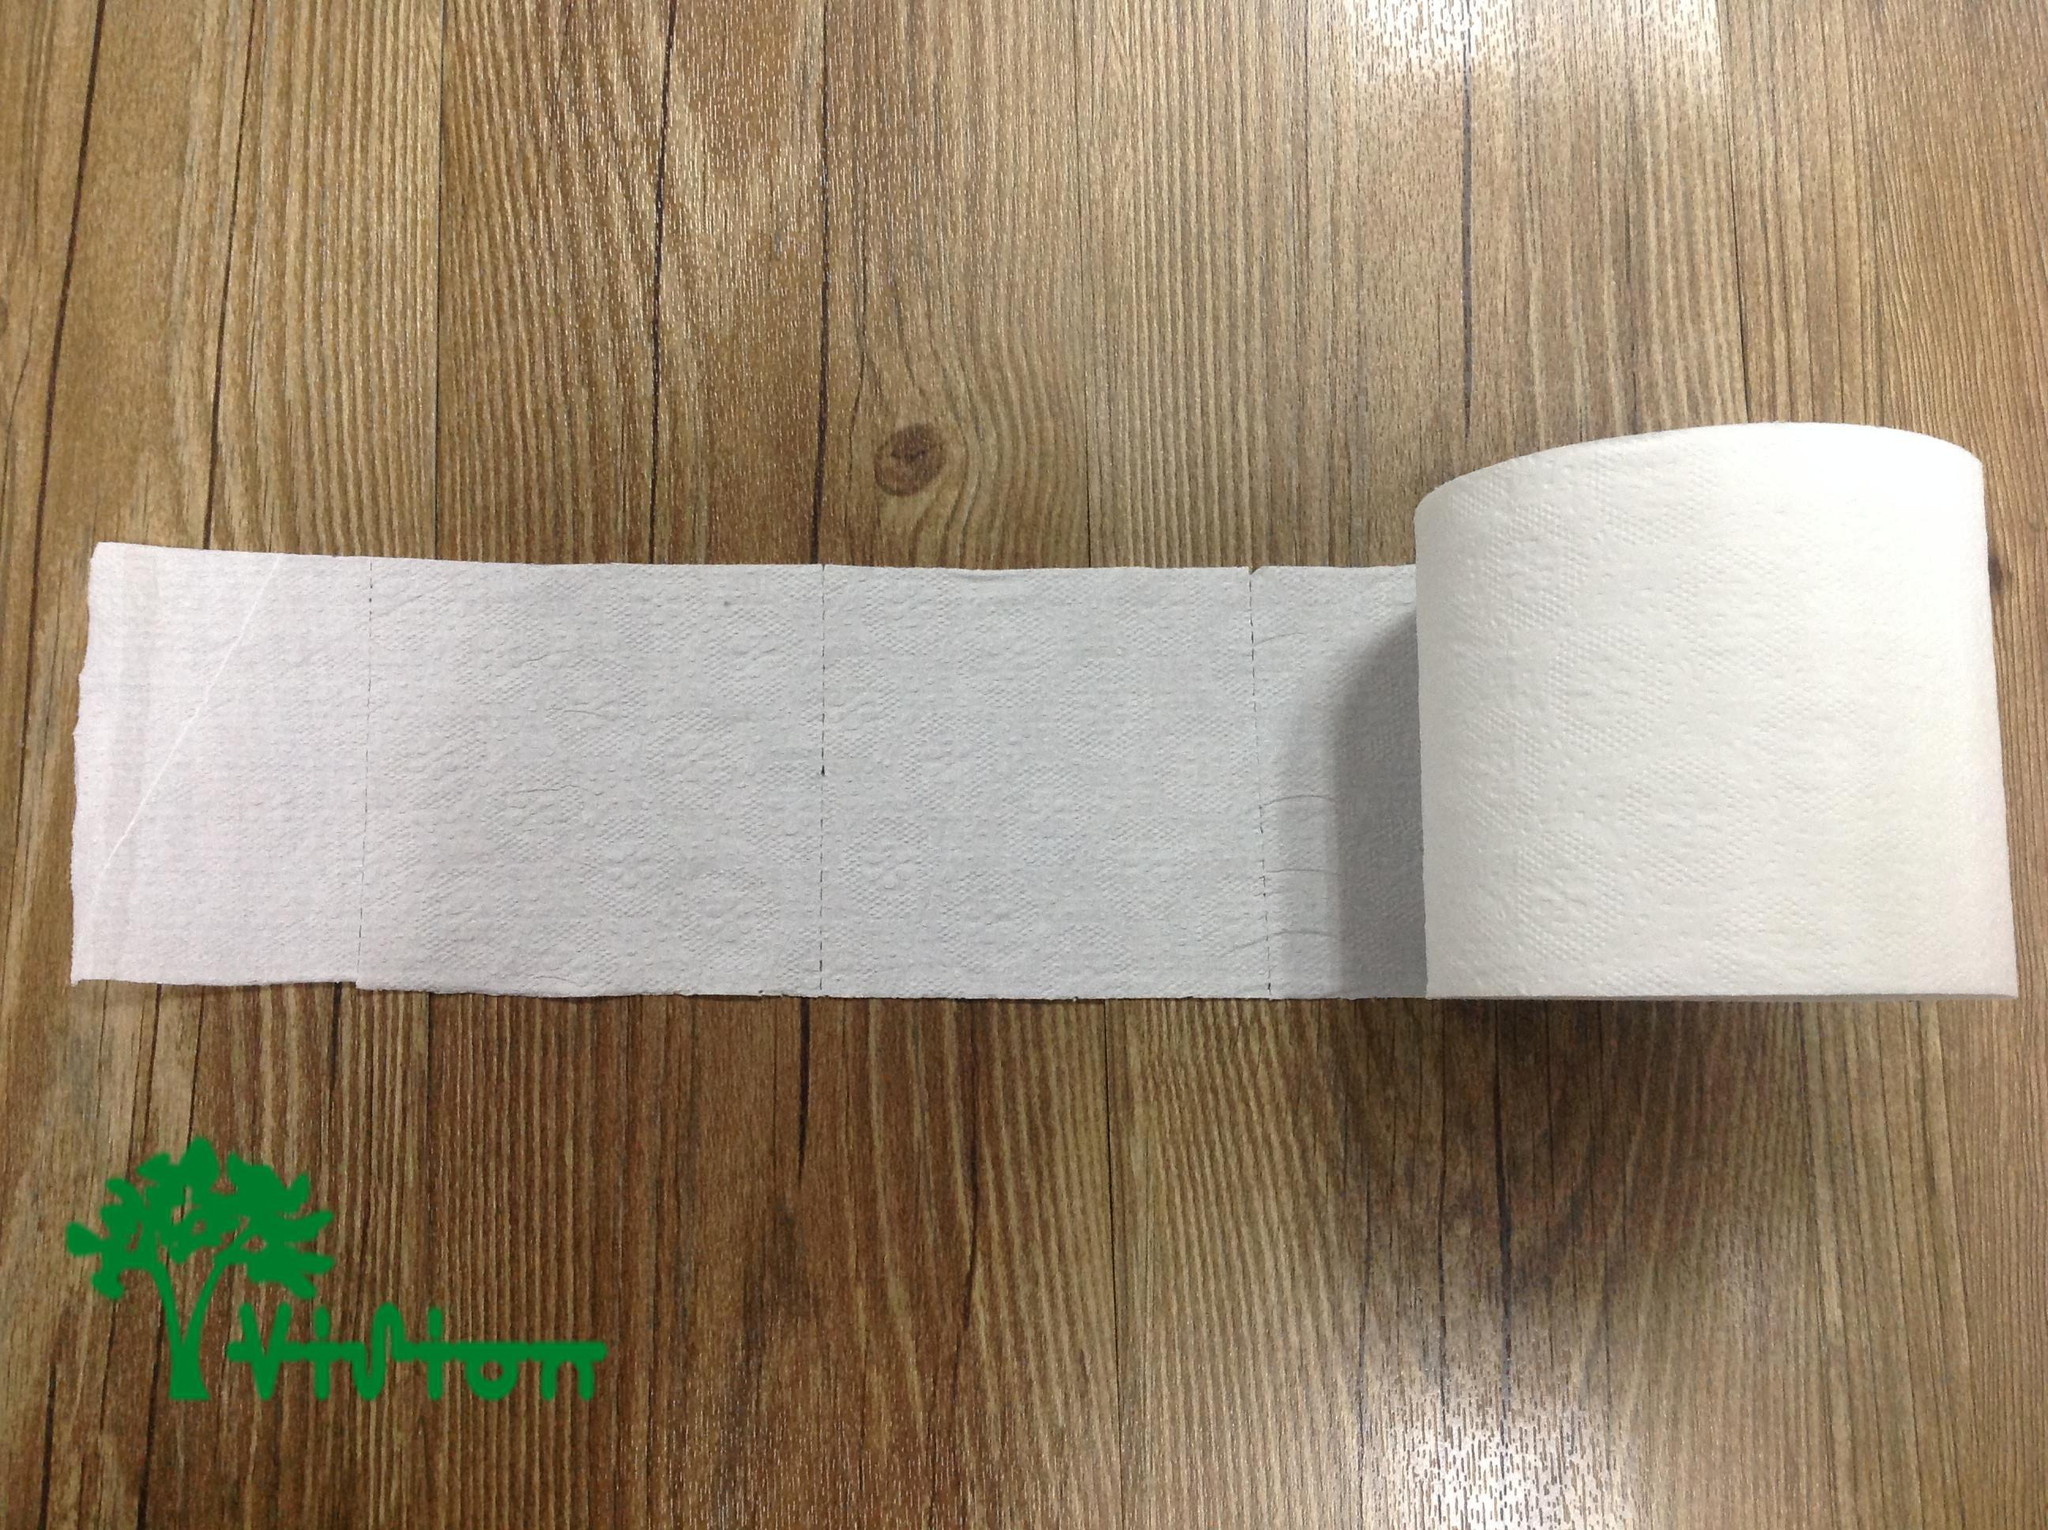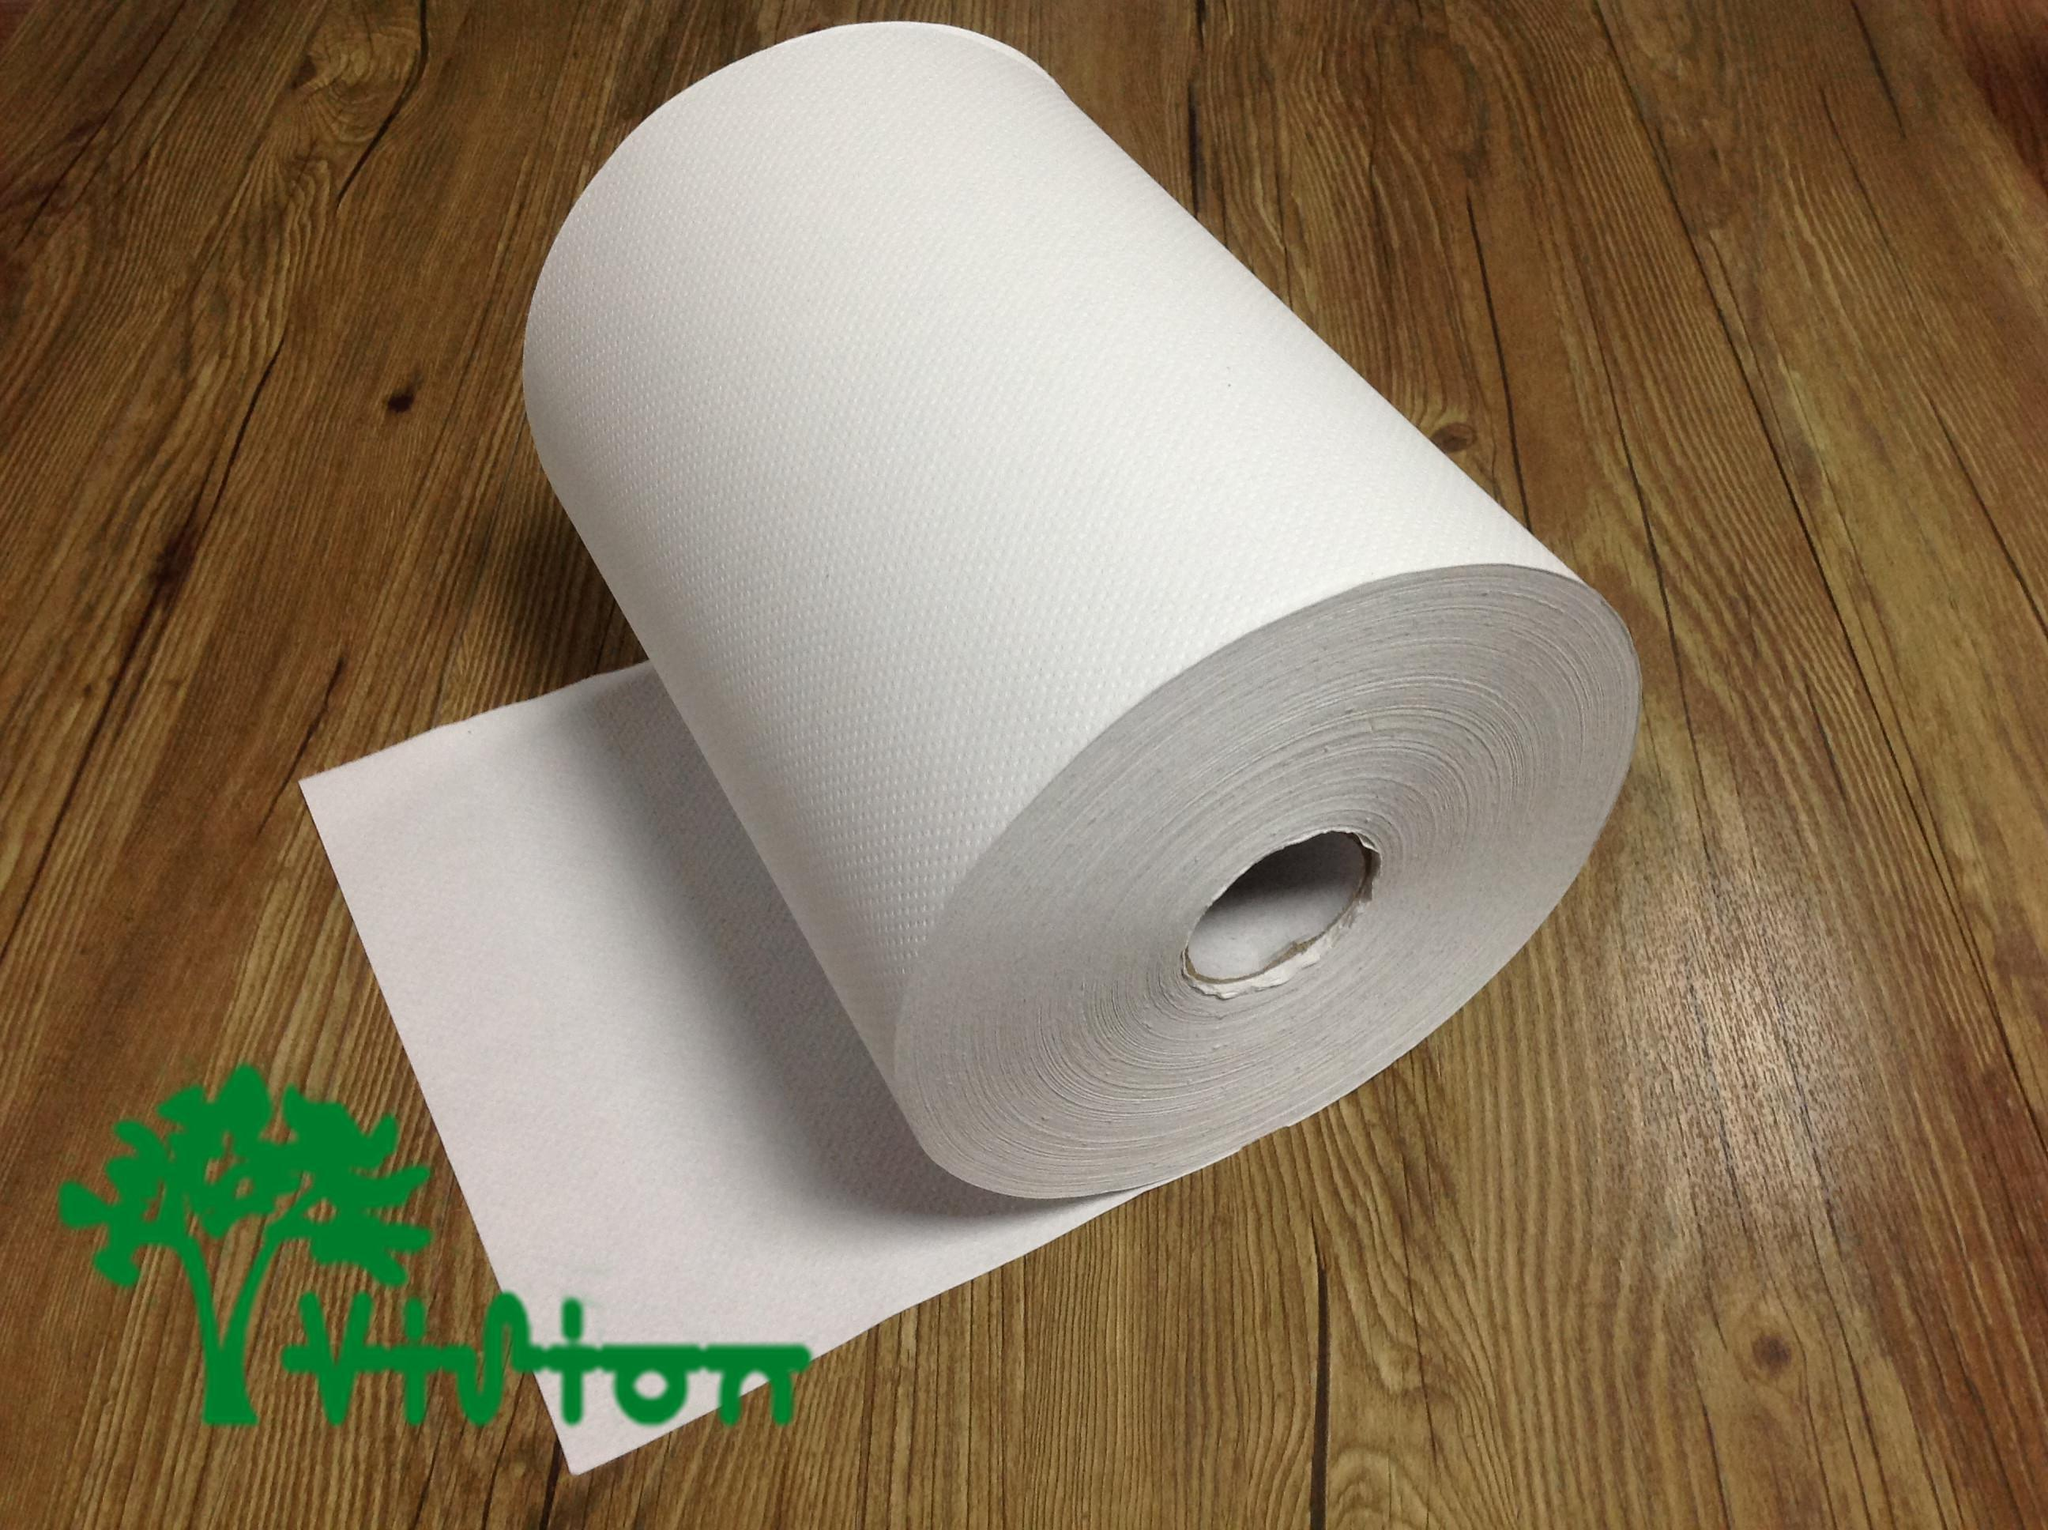The first image is the image on the left, the second image is the image on the right. For the images displayed, is the sentence "There are two rolls lying on a wooden surface." factually correct? Answer yes or no. Yes. 